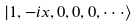Convert formula to latex. <formula><loc_0><loc_0><loc_500><loc_500>| 1 , - i x , 0 , 0 , 0 , \cdot \cdot \cdot \rangle</formula> 